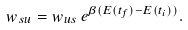<formula> <loc_0><loc_0><loc_500><loc_500>w _ { s u } = w _ { u s } \, e ^ { \beta ( E ( t _ { f } ) - E ( t _ { i } ) ) } .</formula> 